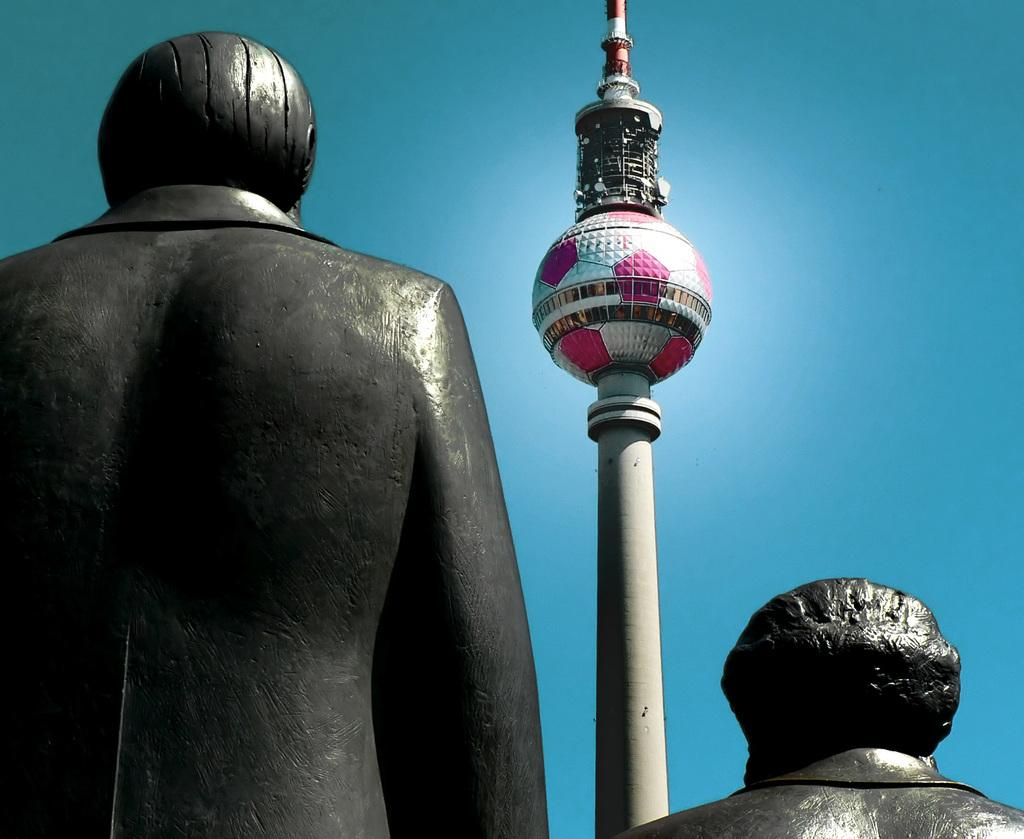What is located in the center of the image? There are statues and a tower in the center of the image. What can be seen in the background of the image? The sky is visible in the image. What type of cord is being used to hold up the statues in the image? There is no cord visible in the image, and the statues are not being held up by any visible means. 